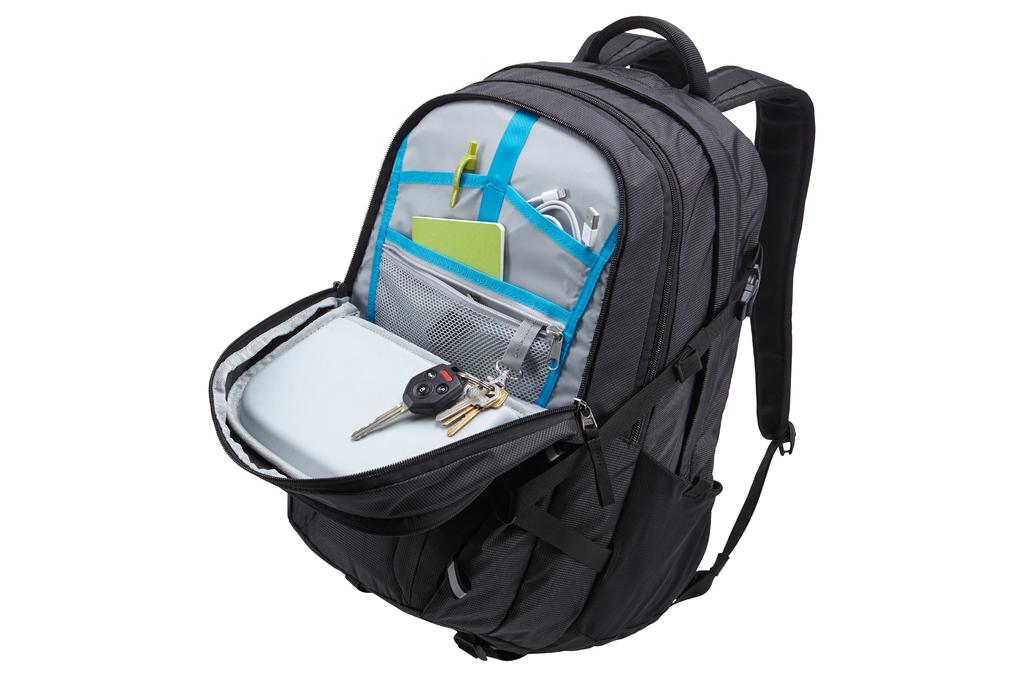What object is visible in the image? There is a backpack in the image. What is the color of the backpack? The backpack is black in color. What is the state of the backpack's zip? The zip of the backpack is open. What items can be found inside the backpack? There is a key, a wire, and a notebook in the backpack. What type of development can be seen along the coast in the image? There is no coast or development visible in the image; it features a backpack with its zip open and items inside. 